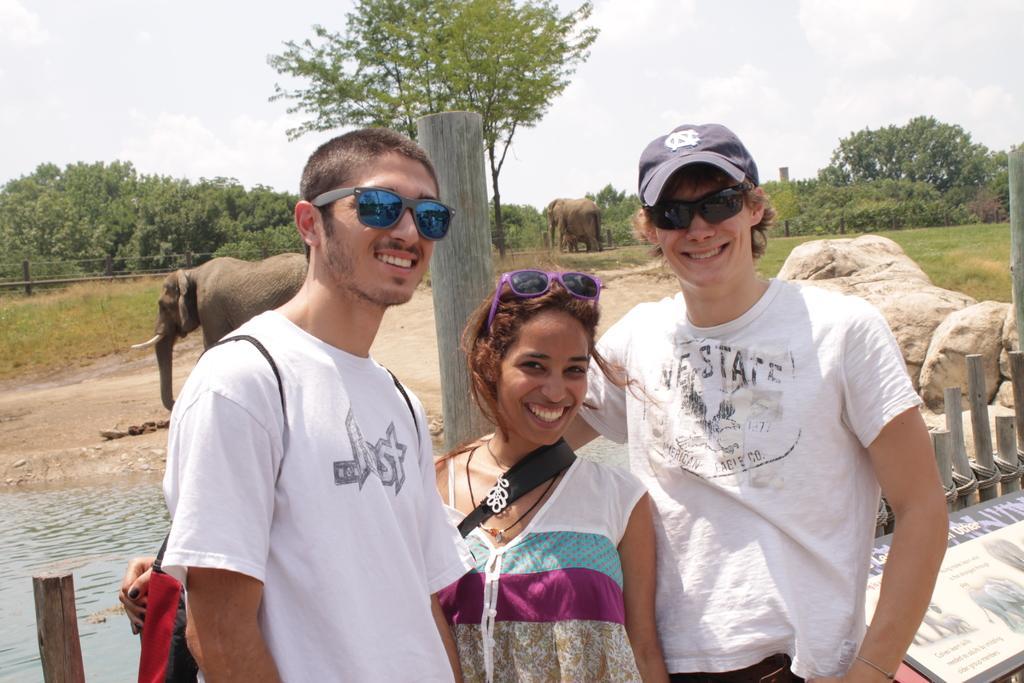How would you summarize this image in a sentence or two? In the image in the center we can see three persons were standing and they were smiling,which we can see on their faces. In the background we can see the sky,clouds,trees,plants,grass,elephants,stones,water,banner and fence. 